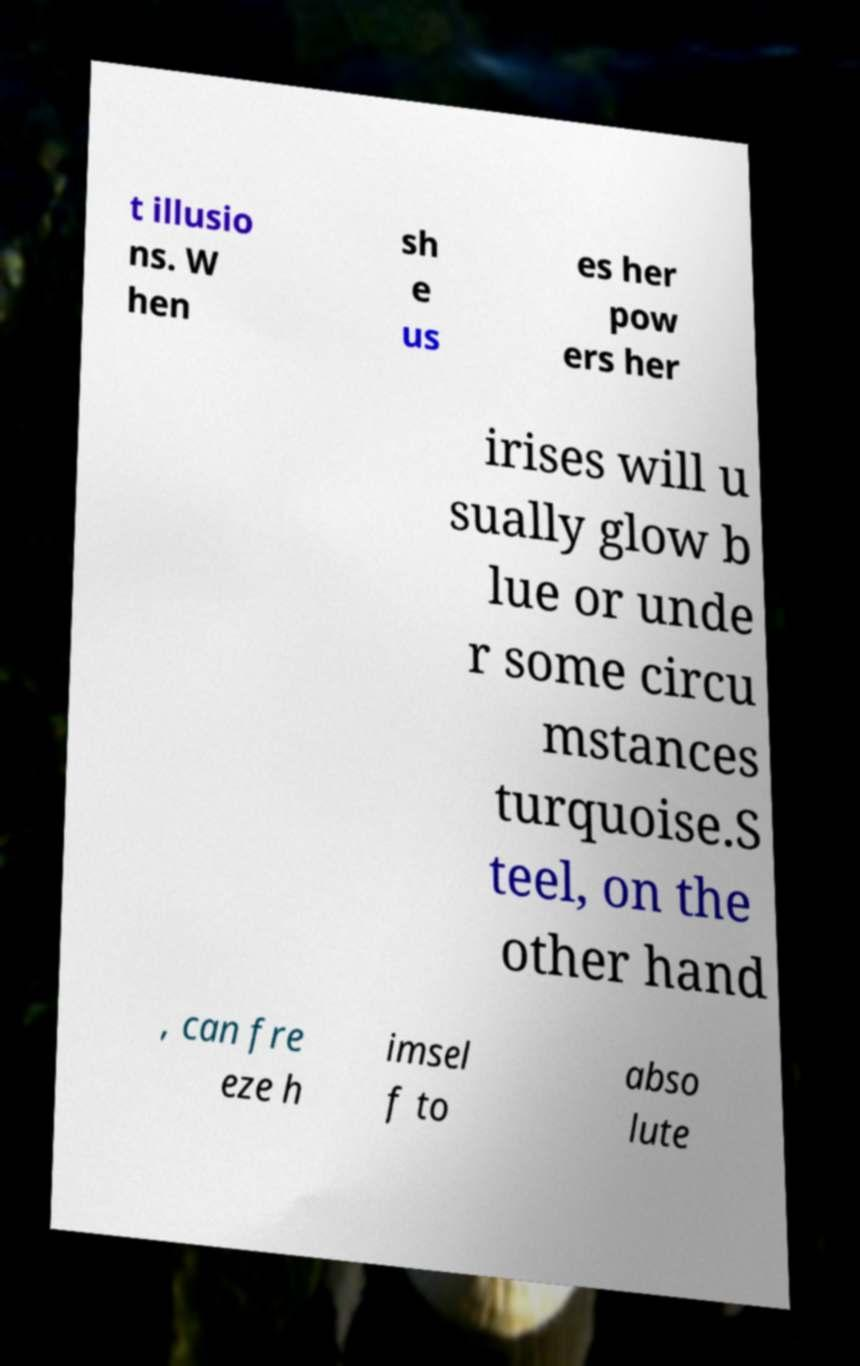Please read and relay the text visible in this image. What does it say? t illusio ns. W hen sh e us es her pow ers her irises will u sually glow b lue or unde r some circu mstances turquoise.S teel, on the other hand , can fre eze h imsel f to abso lute 